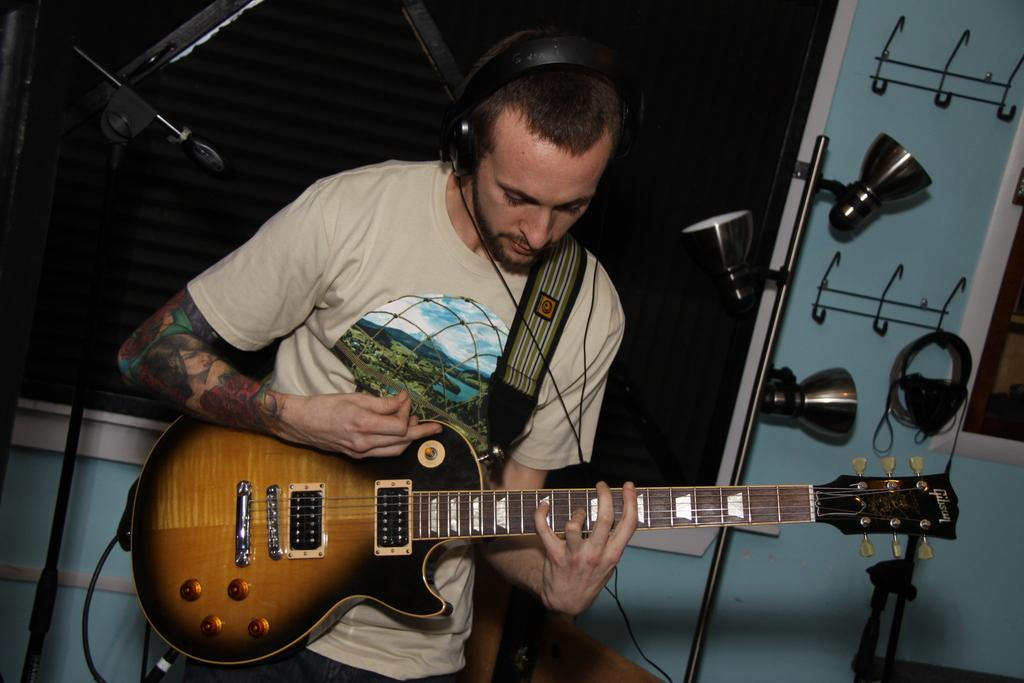What is the man in the image holding? The man is holding a guitar. What is the man wearing on his head? The man is wearing wired headsets. What can be seen in the background of the image? There is a wall and a stand in the background of the image. How would you describe the lighting in the image? The background of the image is dark. How many fish are swimming in the background of the image? There are no fish present in the image; the background features a wall and a stand. What is the man doing with his thumb in the image? There is no indication of the man using his thumb in the image; he is holding a guitar and wearing headsets. 